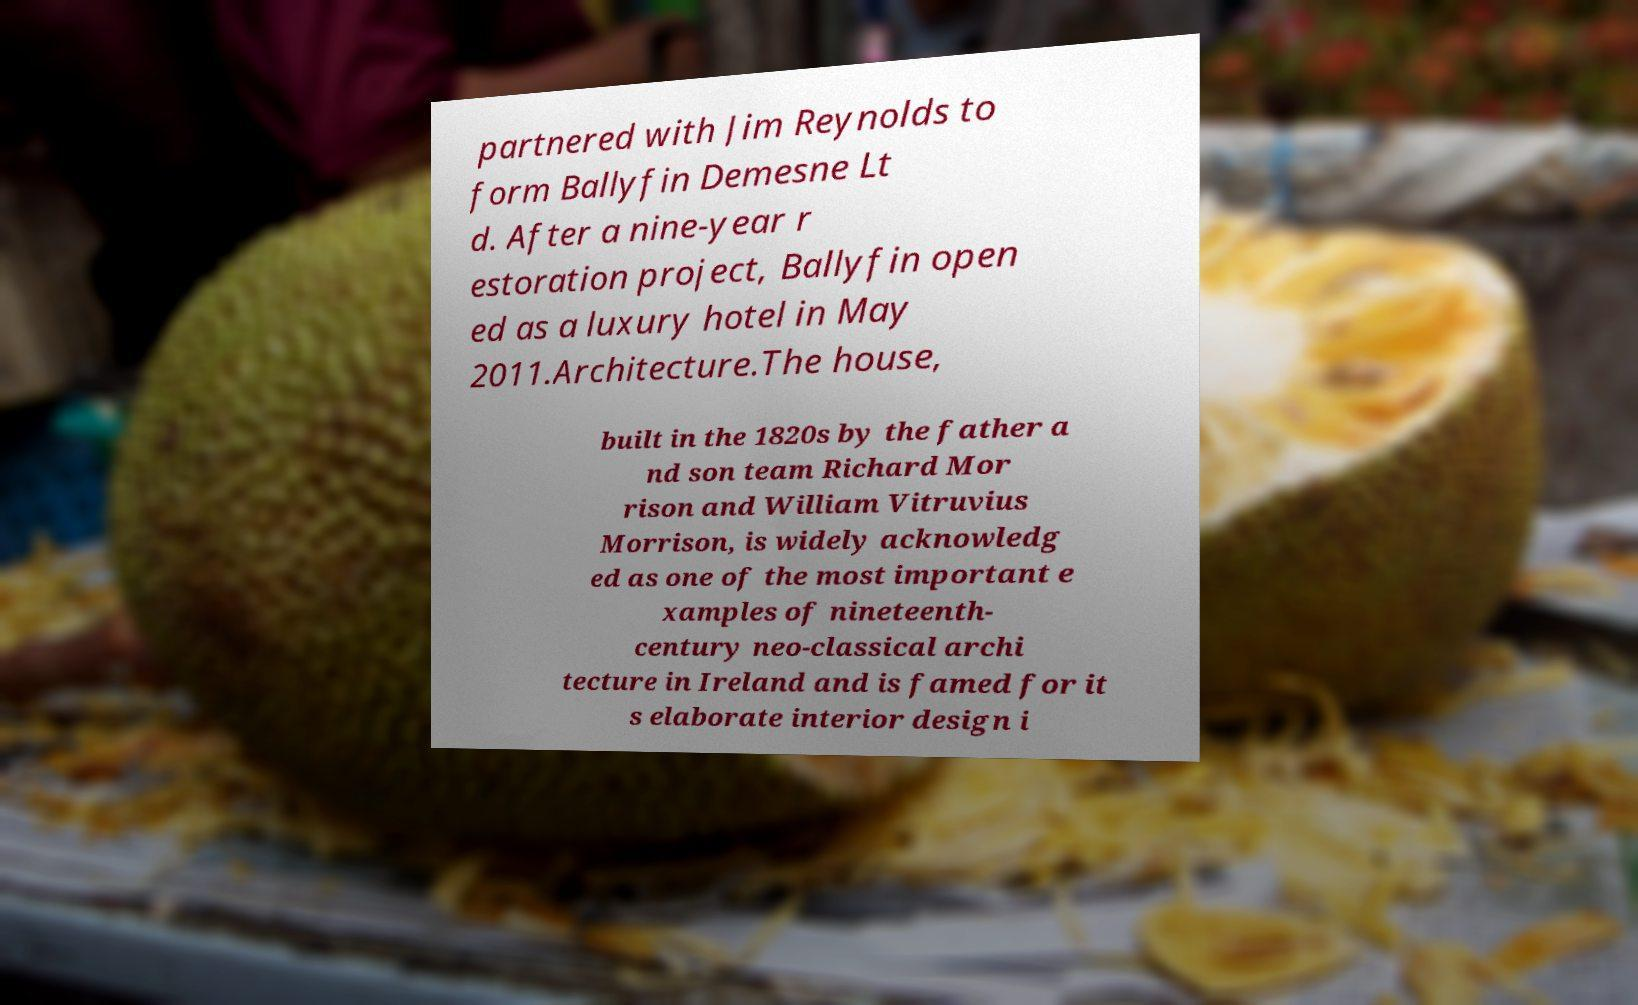Could you extract and type out the text from this image? partnered with Jim Reynolds to form Ballyfin Demesne Lt d. After a nine-year r estoration project, Ballyfin open ed as a luxury hotel in May 2011.Architecture.The house, built in the 1820s by the father a nd son team Richard Mor rison and William Vitruvius Morrison, is widely acknowledg ed as one of the most important e xamples of nineteenth- century neo-classical archi tecture in Ireland and is famed for it s elaborate interior design i 